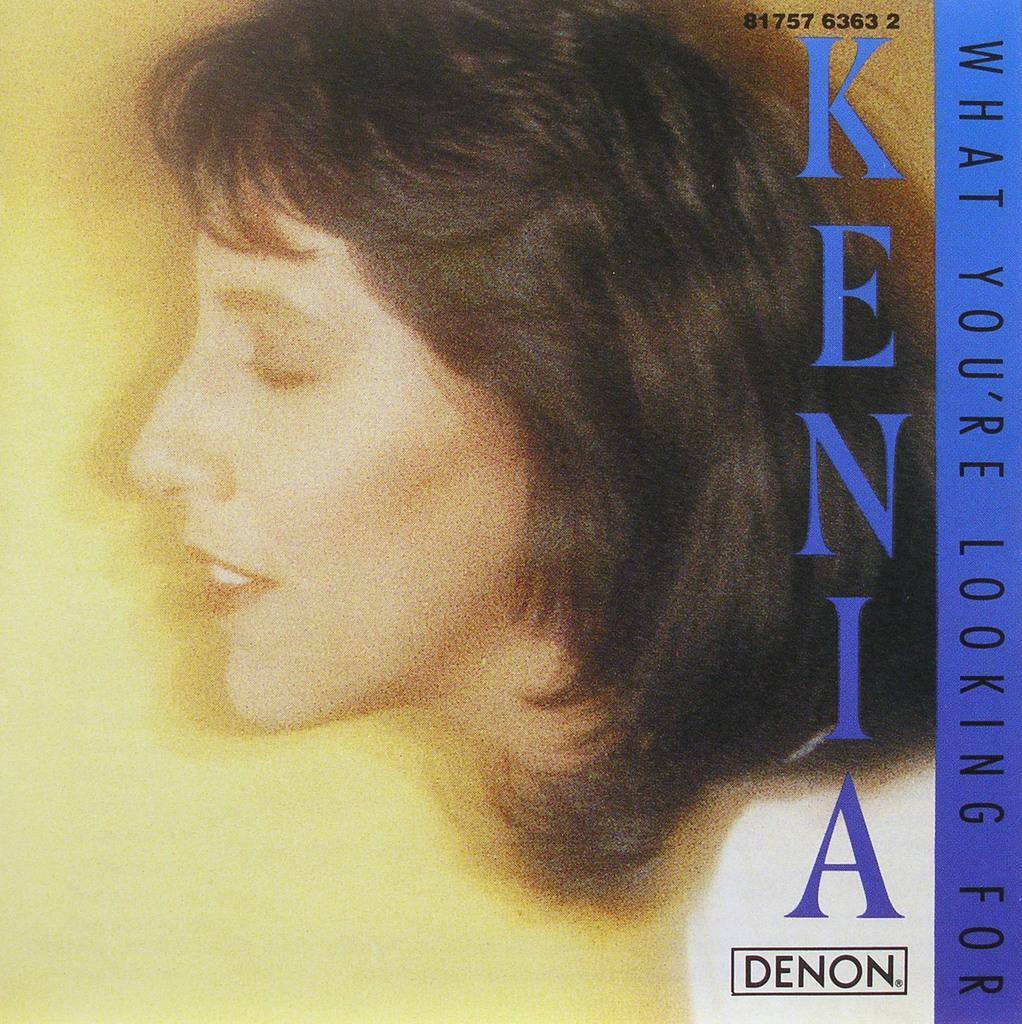Could you give a brief overview of what you see in this image? In the picture I can see a woman's side view. On the right side of the image we can see some edited text which is in blue color. 